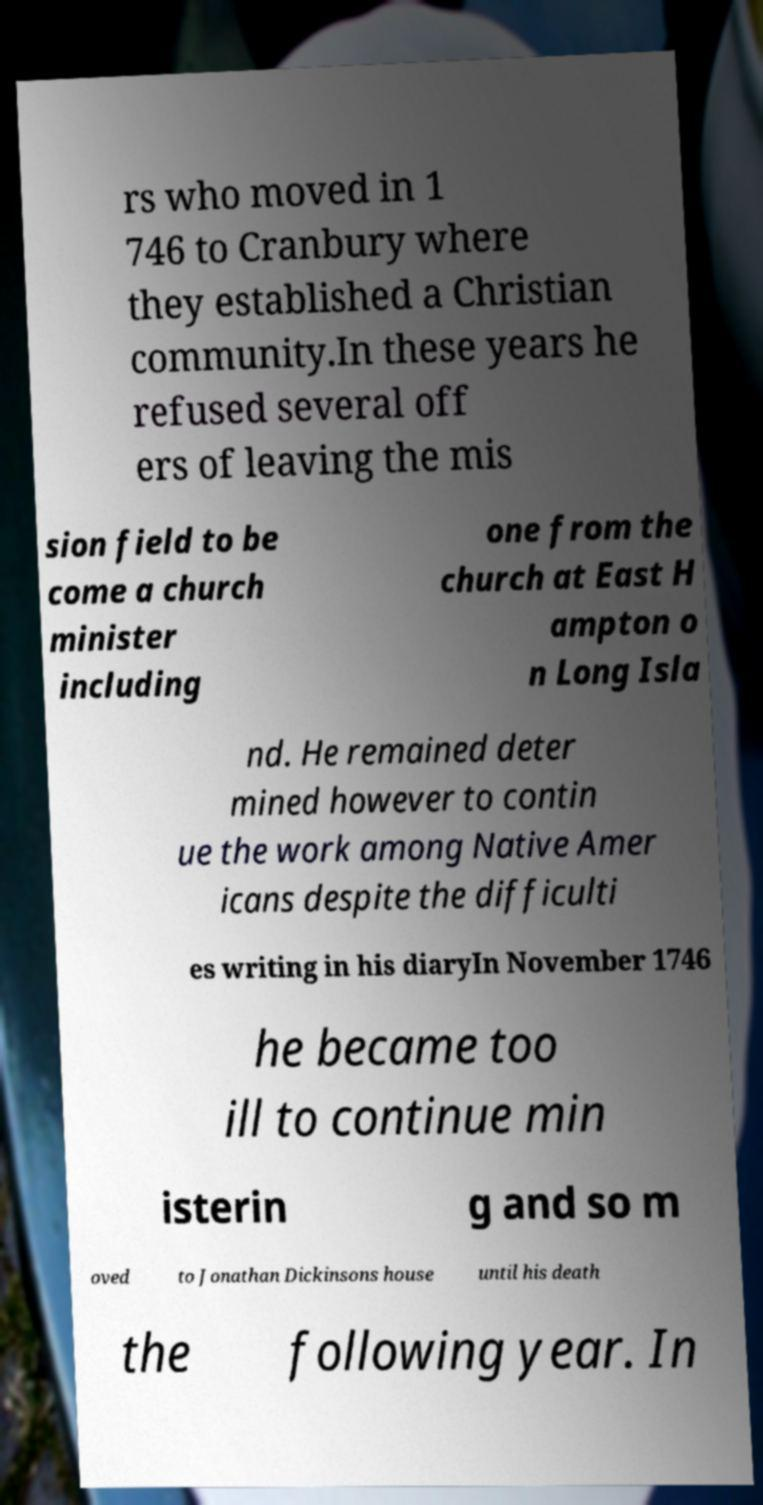Please read and relay the text visible in this image. What does it say? rs who moved in 1 746 to Cranbury where they established a Christian community.In these years he refused several off ers of leaving the mis sion field to be come a church minister including one from the church at East H ampton o n Long Isla nd. He remained deter mined however to contin ue the work among Native Amer icans despite the difficulti es writing in his diaryIn November 1746 he became too ill to continue min isterin g and so m oved to Jonathan Dickinsons house until his death the following year. In 